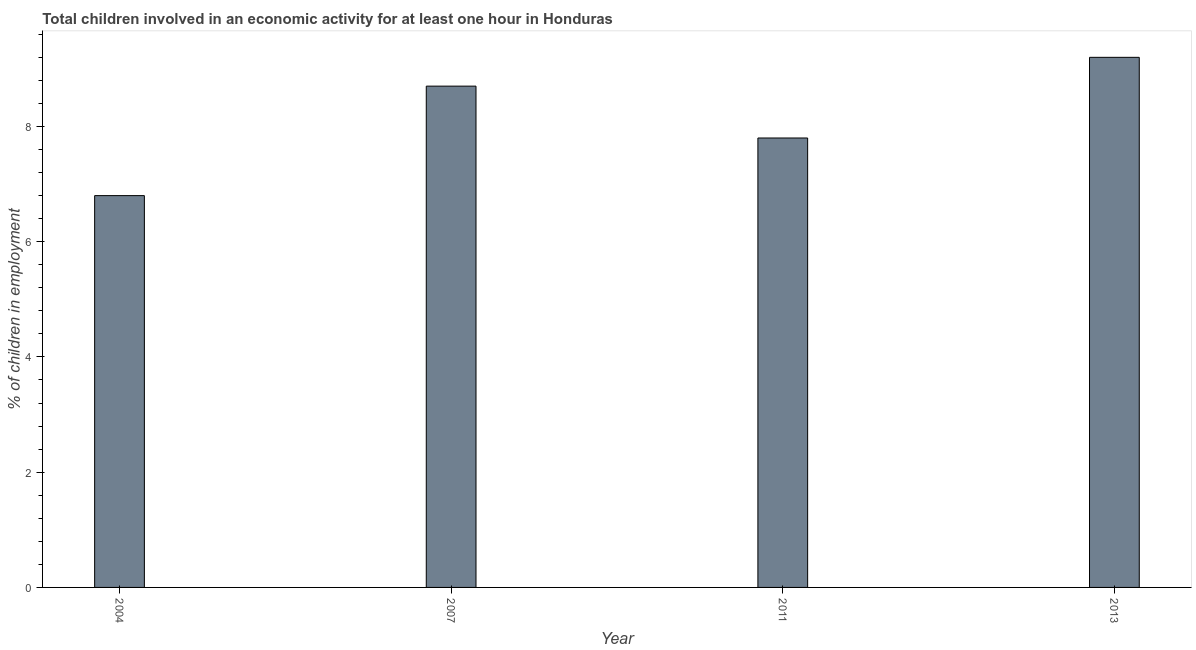Does the graph contain any zero values?
Ensure brevity in your answer.  No. Does the graph contain grids?
Provide a succinct answer. No. What is the title of the graph?
Provide a succinct answer. Total children involved in an economic activity for at least one hour in Honduras. What is the label or title of the Y-axis?
Your response must be concise. % of children in employment. What is the percentage of children in employment in 2011?
Give a very brief answer. 7.8. In which year was the percentage of children in employment maximum?
Provide a succinct answer. 2013. In which year was the percentage of children in employment minimum?
Offer a very short reply. 2004. What is the sum of the percentage of children in employment?
Offer a very short reply. 32.5. What is the difference between the percentage of children in employment in 2007 and 2013?
Keep it short and to the point. -0.5. What is the average percentage of children in employment per year?
Your answer should be very brief. 8.12. What is the median percentage of children in employment?
Your answer should be very brief. 8.25. What is the ratio of the percentage of children in employment in 2007 to that in 2013?
Your answer should be compact. 0.95. What is the difference between the highest and the second highest percentage of children in employment?
Make the answer very short. 0.5. Is the sum of the percentage of children in employment in 2004 and 2007 greater than the maximum percentage of children in employment across all years?
Provide a short and direct response. Yes. How many bars are there?
Keep it short and to the point. 4. How many years are there in the graph?
Your answer should be very brief. 4. What is the % of children in employment in 2011?
Make the answer very short. 7.8. What is the % of children in employment of 2013?
Your response must be concise. 9.2. What is the difference between the % of children in employment in 2004 and 2007?
Your answer should be compact. -1.9. What is the difference between the % of children in employment in 2004 and 2013?
Provide a succinct answer. -2.4. What is the difference between the % of children in employment in 2007 and 2011?
Make the answer very short. 0.9. What is the difference between the % of children in employment in 2007 and 2013?
Offer a very short reply. -0.5. What is the difference between the % of children in employment in 2011 and 2013?
Your answer should be compact. -1.4. What is the ratio of the % of children in employment in 2004 to that in 2007?
Your answer should be compact. 0.78. What is the ratio of the % of children in employment in 2004 to that in 2011?
Your response must be concise. 0.87. What is the ratio of the % of children in employment in 2004 to that in 2013?
Make the answer very short. 0.74. What is the ratio of the % of children in employment in 2007 to that in 2011?
Offer a very short reply. 1.11. What is the ratio of the % of children in employment in 2007 to that in 2013?
Your answer should be very brief. 0.95. What is the ratio of the % of children in employment in 2011 to that in 2013?
Provide a short and direct response. 0.85. 